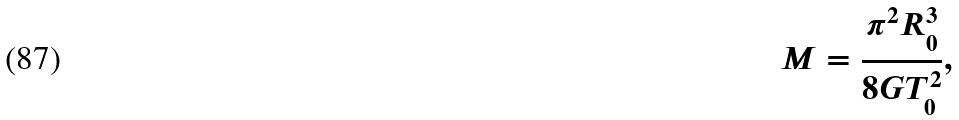<formula> <loc_0><loc_0><loc_500><loc_500>M = \frac { \pi ^ { 2 } R _ { 0 } ^ { 3 } } { 8 G T _ { 0 } ^ { 2 } } ,</formula> 